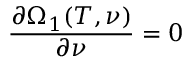<formula> <loc_0><loc_0><loc_500><loc_500>\frac { \partial \Omega _ { 1 } ( T , \nu ) } { \partial \nu } = 0</formula> 